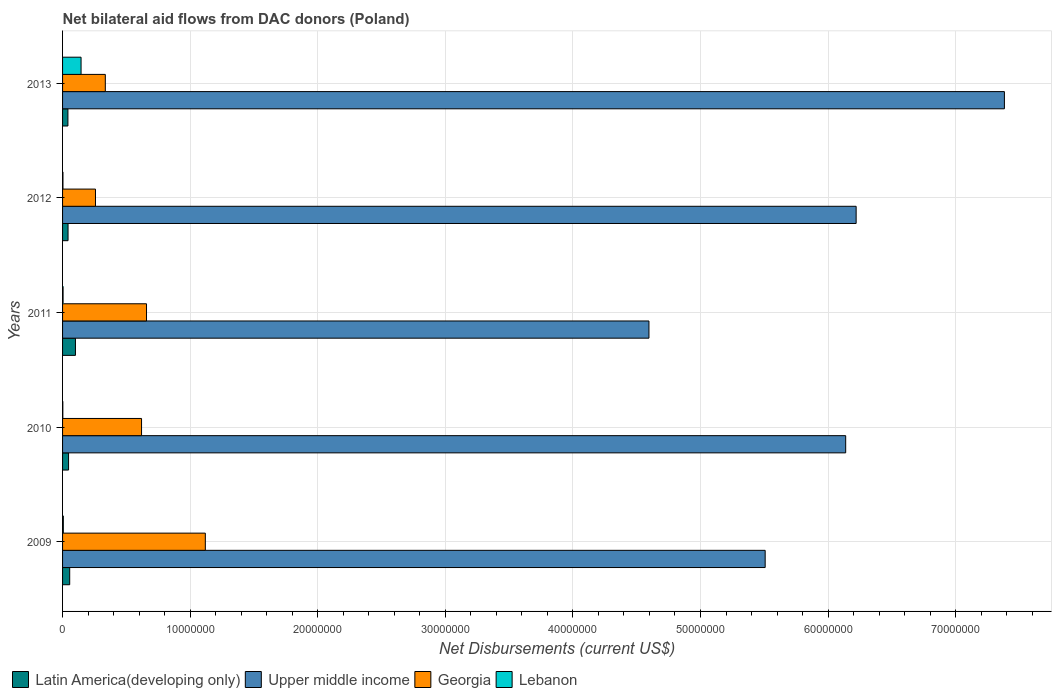How many bars are there on the 2nd tick from the top?
Provide a short and direct response. 4. What is the label of the 2nd group of bars from the top?
Your answer should be very brief. 2012. What is the net bilateral aid flows in Lebanon in 2012?
Provide a short and direct response. 3.00e+04. Across all years, what is the maximum net bilateral aid flows in Upper middle income?
Your answer should be compact. 7.38e+07. Across all years, what is the minimum net bilateral aid flows in Lebanon?
Make the answer very short. 2.00e+04. In which year was the net bilateral aid flows in Lebanon maximum?
Your response must be concise. 2013. What is the total net bilateral aid flows in Georgia in the graph?
Give a very brief answer. 2.99e+07. What is the difference between the net bilateral aid flows in Upper middle income in 2010 and that in 2013?
Ensure brevity in your answer.  -1.24e+07. What is the difference between the net bilateral aid flows in Georgia in 2010 and the net bilateral aid flows in Lebanon in 2013?
Offer a very short reply. 4.74e+06. In the year 2009, what is the difference between the net bilateral aid flows in Upper middle income and net bilateral aid flows in Latin America(developing only)?
Offer a very short reply. 5.45e+07. In how many years, is the net bilateral aid flows in Lebanon greater than 36000000 US$?
Your answer should be very brief. 0. What is the ratio of the net bilateral aid flows in Latin America(developing only) in 2009 to that in 2012?
Offer a very short reply. 1.3. What is the difference between the highest and the second highest net bilateral aid flows in Latin America(developing only)?
Your answer should be compact. 4.50e+05. What is the difference between the highest and the lowest net bilateral aid flows in Georgia?
Your answer should be compact. 8.61e+06. In how many years, is the net bilateral aid flows in Latin America(developing only) greater than the average net bilateral aid flows in Latin America(developing only) taken over all years?
Make the answer very short. 1. What does the 2nd bar from the top in 2013 represents?
Your response must be concise. Georgia. What does the 3rd bar from the bottom in 2012 represents?
Keep it short and to the point. Georgia. Is it the case that in every year, the sum of the net bilateral aid flows in Latin America(developing only) and net bilateral aid flows in Lebanon is greater than the net bilateral aid flows in Georgia?
Offer a terse response. No. Are the values on the major ticks of X-axis written in scientific E-notation?
Provide a short and direct response. No. Does the graph contain any zero values?
Your answer should be very brief. No. Does the graph contain grids?
Your response must be concise. Yes. What is the title of the graph?
Keep it short and to the point. Net bilateral aid flows from DAC donors (Poland). What is the label or title of the X-axis?
Provide a succinct answer. Net Disbursements (current US$). What is the Net Disbursements (current US$) of Latin America(developing only) in 2009?
Keep it short and to the point. 5.60e+05. What is the Net Disbursements (current US$) in Upper middle income in 2009?
Provide a short and direct response. 5.51e+07. What is the Net Disbursements (current US$) of Georgia in 2009?
Give a very brief answer. 1.12e+07. What is the Net Disbursements (current US$) in Upper middle income in 2010?
Offer a terse response. 6.14e+07. What is the Net Disbursements (current US$) of Georgia in 2010?
Your answer should be very brief. 6.19e+06. What is the Net Disbursements (current US$) in Lebanon in 2010?
Give a very brief answer. 2.00e+04. What is the Net Disbursements (current US$) in Latin America(developing only) in 2011?
Ensure brevity in your answer.  1.01e+06. What is the Net Disbursements (current US$) of Upper middle income in 2011?
Provide a short and direct response. 4.60e+07. What is the Net Disbursements (current US$) of Georgia in 2011?
Give a very brief answer. 6.58e+06. What is the Net Disbursements (current US$) of Lebanon in 2011?
Offer a terse response. 4.00e+04. What is the Net Disbursements (current US$) of Upper middle income in 2012?
Offer a terse response. 6.22e+07. What is the Net Disbursements (current US$) in Georgia in 2012?
Offer a very short reply. 2.58e+06. What is the Net Disbursements (current US$) of Lebanon in 2012?
Offer a very short reply. 3.00e+04. What is the Net Disbursements (current US$) in Upper middle income in 2013?
Offer a terse response. 7.38e+07. What is the Net Disbursements (current US$) of Georgia in 2013?
Provide a short and direct response. 3.35e+06. What is the Net Disbursements (current US$) in Lebanon in 2013?
Provide a succinct answer. 1.45e+06. Across all years, what is the maximum Net Disbursements (current US$) of Latin America(developing only)?
Your answer should be very brief. 1.01e+06. Across all years, what is the maximum Net Disbursements (current US$) of Upper middle income?
Offer a very short reply. 7.38e+07. Across all years, what is the maximum Net Disbursements (current US$) in Georgia?
Your answer should be compact. 1.12e+07. Across all years, what is the maximum Net Disbursements (current US$) in Lebanon?
Offer a terse response. 1.45e+06. Across all years, what is the minimum Net Disbursements (current US$) in Upper middle income?
Keep it short and to the point. 4.60e+07. Across all years, what is the minimum Net Disbursements (current US$) in Georgia?
Keep it short and to the point. 2.58e+06. What is the total Net Disbursements (current US$) in Latin America(developing only) in the graph?
Your answer should be compact. 2.89e+06. What is the total Net Disbursements (current US$) of Upper middle income in the graph?
Your answer should be compact. 2.98e+08. What is the total Net Disbursements (current US$) of Georgia in the graph?
Your answer should be very brief. 2.99e+07. What is the total Net Disbursements (current US$) of Lebanon in the graph?
Offer a terse response. 1.60e+06. What is the difference between the Net Disbursements (current US$) of Upper middle income in 2009 and that in 2010?
Provide a succinct answer. -6.31e+06. What is the difference between the Net Disbursements (current US$) of Georgia in 2009 and that in 2010?
Provide a short and direct response. 5.00e+06. What is the difference between the Net Disbursements (current US$) in Lebanon in 2009 and that in 2010?
Offer a very short reply. 4.00e+04. What is the difference between the Net Disbursements (current US$) of Latin America(developing only) in 2009 and that in 2011?
Offer a very short reply. -4.50e+05. What is the difference between the Net Disbursements (current US$) of Upper middle income in 2009 and that in 2011?
Provide a short and direct response. 9.11e+06. What is the difference between the Net Disbursements (current US$) in Georgia in 2009 and that in 2011?
Make the answer very short. 4.61e+06. What is the difference between the Net Disbursements (current US$) in Latin America(developing only) in 2009 and that in 2012?
Provide a succinct answer. 1.30e+05. What is the difference between the Net Disbursements (current US$) of Upper middle income in 2009 and that in 2012?
Keep it short and to the point. -7.13e+06. What is the difference between the Net Disbursements (current US$) in Georgia in 2009 and that in 2012?
Provide a short and direct response. 8.61e+06. What is the difference between the Net Disbursements (current US$) of Lebanon in 2009 and that in 2012?
Your answer should be very brief. 3.00e+04. What is the difference between the Net Disbursements (current US$) of Upper middle income in 2009 and that in 2013?
Your answer should be very brief. -1.88e+07. What is the difference between the Net Disbursements (current US$) of Georgia in 2009 and that in 2013?
Provide a succinct answer. 7.84e+06. What is the difference between the Net Disbursements (current US$) of Lebanon in 2009 and that in 2013?
Provide a succinct answer. -1.39e+06. What is the difference between the Net Disbursements (current US$) in Latin America(developing only) in 2010 and that in 2011?
Your response must be concise. -5.40e+05. What is the difference between the Net Disbursements (current US$) in Upper middle income in 2010 and that in 2011?
Your answer should be compact. 1.54e+07. What is the difference between the Net Disbursements (current US$) in Georgia in 2010 and that in 2011?
Offer a terse response. -3.90e+05. What is the difference between the Net Disbursements (current US$) in Upper middle income in 2010 and that in 2012?
Keep it short and to the point. -8.20e+05. What is the difference between the Net Disbursements (current US$) of Georgia in 2010 and that in 2012?
Keep it short and to the point. 3.61e+06. What is the difference between the Net Disbursements (current US$) in Lebanon in 2010 and that in 2012?
Provide a succinct answer. -10000. What is the difference between the Net Disbursements (current US$) in Latin America(developing only) in 2010 and that in 2013?
Provide a succinct answer. 5.00e+04. What is the difference between the Net Disbursements (current US$) of Upper middle income in 2010 and that in 2013?
Give a very brief answer. -1.24e+07. What is the difference between the Net Disbursements (current US$) of Georgia in 2010 and that in 2013?
Provide a succinct answer. 2.84e+06. What is the difference between the Net Disbursements (current US$) in Lebanon in 2010 and that in 2013?
Keep it short and to the point. -1.43e+06. What is the difference between the Net Disbursements (current US$) of Latin America(developing only) in 2011 and that in 2012?
Ensure brevity in your answer.  5.80e+05. What is the difference between the Net Disbursements (current US$) in Upper middle income in 2011 and that in 2012?
Your response must be concise. -1.62e+07. What is the difference between the Net Disbursements (current US$) of Georgia in 2011 and that in 2012?
Your answer should be very brief. 4.00e+06. What is the difference between the Net Disbursements (current US$) of Latin America(developing only) in 2011 and that in 2013?
Ensure brevity in your answer.  5.90e+05. What is the difference between the Net Disbursements (current US$) in Upper middle income in 2011 and that in 2013?
Your answer should be compact. -2.79e+07. What is the difference between the Net Disbursements (current US$) in Georgia in 2011 and that in 2013?
Ensure brevity in your answer.  3.23e+06. What is the difference between the Net Disbursements (current US$) of Lebanon in 2011 and that in 2013?
Keep it short and to the point. -1.41e+06. What is the difference between the Net Disbursements (current US$) in Latin America(developing only) in 2012 and that in 2013?
Keep it short and to the point. 10000. What is the difference between the Net Disbursements (current US$) in Upper middle income in 2012 and that in 2013?
Your response must be concise. -1.16e+07. What is the difference between the Net Disbursements (current US$) of Georgia in 2012 and that in 2013?
Make the answer very short. -7.70e+05. What is the difference between the Net Disbursements (current US$) in Lebanon in 2012 and that in 2013?
Give a very brief answer. -1.42e+06. What is the difference between the Net Disbursements (current US$) of Latin America(developing only) in 2009 and the Net Disbursements (current US$) of Upper middle income in 2010?
Provide a succinct answer. -6.08e+07. What is the difference between the Net Disbursements (current US$) in Latin America(developing only) in 2009 and the Net Disbursements (current US$) in Georgia in 2010?
Offer a very short reply. -5.63e+06. What is the difference between the Net Disbursements (current US$) of Latin America(developing only) in 2009 and the Net Disbursements (current US$) of Lebanon in 2010?
Give a very brief answer. 5.40e+05. What is the difference between the Net Disbursements (current US$) of Upper middle income in 2009 and the Net Disbursements (current US$) of Georgia in 2010?
Provide a succinct answer. 4.89e+07. What is the difference between the Net Disbursements (current US$) of Upper middle income in 2009 and the Net Disbursements (current US$) of Lebanon in 2010?
Keep it short and to the point. 5.50e+07. What is the difference between the Net Disbursements (current US$) of Georgia in 2009 and the Net Disbursements (current US$) of Lebanon in 2010?
Offer a very short reply. 1.12e+07. What is the difference between the Net Disbursements (current US$) of Latin America(developing only) in 2009 and the Net Disbursements (current US$) of Upper middle income in 2011?
Give a very brief answer. -4.54e+07. What is the difference between the Net Disbursements (current US$) in Latin America(developing only) in 2009 and the Net Disbursements (current US$) in Georgia in 2011?
Ensure brevity in your answer.  -6.02e+06. What is the difference between the Net Disbursements (current US$) of Latin America(developing only) in 2009 and the Net Disbursements (current US$) of Lebanon in 2011?
Offer a terse response. 5.20e+05. What is the difference between the Net Disbursements (current US$) in Upper middle income in 2009 and the Net Disbursements (current US$) in Georgia in 2011?
Provide a short and direct response. 4.85e+07. What is the difference between the Net Disbursements (current US$) of Upper middle income in 2009 and the Net Disbursements (current US$) of Lebanon in 2011?
Your response must be concise. 5.50e+07. What is the difference between the Net Disbursements (current US$) of Georgia in 2009 and the Net Disbursements (current US$) of Lebanon in 2011?
Keep it short and to the point. 1.12e+07. What is the difference between the Net Disbursements (current US$) in Latin America(developing only) in 2009 and the Net Disbursements (current US$) in Upper middle income in 2012?
Your answer should be compact. -6.16e+07. What is the difference between the Net Disbursements (current US$) of Latin America(developing only) in 2009 and the Net Disbursements (current US$) of Georgia in 2012?
Provide a succinct answer. -2.02e+06. What is the difference between the Net Disbursements (current US$) of Latin America(developing only) in 2009 and the Net Disbursements (current US$) of Lebanon in 2012?
Your answer should be compact. 5.30e+05. What is the difference between the Net Disbursements (current US$) in Upper middle income in 2009 and the Net Disbursements (current US$) in Georgia in 2012?
Your answer should be very brief. 5.25e+07. What is the difference between the Net Disbursements (current US$) of Upper middle income in 2009 and the Net Disbursements (current US$) of Lebanon in 2012?
Your answer should be compact. 5.50e+07. What is the difference between the Net Disbursements (current US$) of Georgia in 2009 and the Net Disbursements (current US$) of Lebanon in 2012?
Provide a short and direct response. 1.12e+07. What is the difference between the Net Disbursements (current US$) in Latin America(developing only) in 2009 and the Net Disbursements (current US$) in Upper middle income in 2013?
Provide a succinct answer. -7.33e+07. What is the difference between the Net Disbursements (current US$) in Latin America(developing only) in 2009 and the Net Disbursements (current US$) in Georgia in 2013?
Offer a terse response. -2.79e+06. What is the difference between the Net Disbursements (current US$) in Latin America(developing only) in 2009 and the Net Disbursements (current US$) in Lebanon in 2013?
Provide a succinct answer. -8.90e+05. What is the difference between the Net Disbursements (current US$) in Upper middle income in 2009 and the Net Disbursements (current US$) in Georgia in 2013?
Give a very brief answer. 5.17e+07. What is the difference between the Net Disbursements (current US$) in Upper middle income in 2009 and the Net Disbursements (current US$) in Lebanon in 2013?
Offer a very short reply. 5.36e+07. What is the difference between the Net Disbursements (current US$) in Georgia in 2009 and the Net Disbursements (current US$) in Lebanon in 2013?
Offer a very short reply. 9.74e+06. What is the difference between the Net Disbursements (current US$) of Latin America(developing only) in 2010 and the Net Disbursements (current US$) of Upper middle income in 2011?
Give a very brief answer. -4.55e+07. What is the difference between the Net Disbursements (current US$) in Latin America(developing only) in 2010 and the Net Disbursements (current US$) in Georgia in 2011?
Your answer should be compact. -6.11e+06. What is the difference between the Net Disbursements (current US$) in Upper middle income in 2010 and the Net Disbursements (current US$) in Georgia in 2011?
Your answer should be compact. 5.48e+07. What is the difference between the Net Disbursements (current US$) of Upper middle income in 2010 and the Net Disbursements (current US$) of Lebanon in 2011?
Your response must be concise. 6.13e+07. What is the difference between the Net Disbursements (current US$) in Georgia in 2010 and the Net Disbursements (current US$) in Lebanon in 2011?
Provide a succinct answer. 6.15e+06. What is the difference between the Net Disbursements (current US$) in Latin America(developing only) in 2010 and the Net Disbursements (current US$) in Upper middle income in 2012?
Ensure brevity in your answer.  -6.17e+07. What is the difference between the Net Disbursements (current US$) in Latin America(developing only) in 2010 and the Net Disbursements (current US$) in Georgia in 2012?
Keep it short and to the point. -2.11e+06. What is the difference between the Net Disbursements (current US$) of Latin America(developing only) in 2010 and the Net Disbursements (current US$) of Lebanon in 2012?
Provide a short and direct response. 4.40e+05. What is the difference between the Net Disbursements (current US$) of Upper middle income in 2010 and the Net Disbursements (current US$) of Georgia in 2012?
Give a very brief answer. 5.88e+07. What is the difference between the Net Disbursements (current US$) in Upper middle income in 2010 and the Net Disbursements (current US$) in Lebanon in 2012?
Your answer should be very brief. 6.14e+07. What is the difference between the Net Disbursements (current US$) in Georgia in 2010 and the Net Disbursements (current US$) in Lebanon in 2012?
Your answer should be very brief. 6.16e+06. What is the difference between the Net Disbursements (current US$) of Latin America(developing only) in 2010 and the Net Disbursements (current US$) of Upper middle income in 2013?
Provide a short and direct response. -7.34e+07. What is the difference between the Net Disbursements (current US$) in Latin America(developing only) in 2010 and the Net Disbursements (current US$) in Georgia in 2013?
Provide a short and direct response. -2.88e+06. What is the difference between the Net Disbursements (current US$) in Latin America(developing only) in 2010 and the Net Disbursements (current US$) in Lebanon in 2013?
Ensure brevity in your answer.  -9.80e+05. What is the difference between the Net Disbursements (current US$) of Upper middle income in 2010 and the Net Disbursements (current US$) of Georgia in 2013?
Your answer should be compact. 5.80e+07. What is the difference between the Net Disbursements (current US$) of Upper middle income in 2010 and the Net Disbursements (current US$) of Lebanon in 2013?
Provide a succinct answer. 5.99e+07. What is the difference between the Net Disbursements (current US$) in Georgia in 2010 and the Net Disbursements (current US$) in Lebanon in 2013?
Give a very brief answer. 4.74e+06. What is the difference between the Net Disbursements (current US$) of Latin America(developing only) in 2011 and the Net Disbursements (current US$) of Upper middle income in 2012?
Offer a very short reply. -6.12e+07. What is the difference between the Net Disbursements (current US$) of Latin America(developing only) in 2011 and the Net Disbursements (current US$) of Georgia in 2012?
Your answer should be very brief. -1.57e+06. What is the difference between the Net Disbursements (current US$) in Latin America(developing only) in 2011 and the Net Disbursements (current US$) in Lebanon in 2012?
Make the answer very short. 9.80e+05. What is the difference between the Net Disbursements (current US$) in Upper middle income in 2011 and the Net Disbursements (current US$) in Georgia in 2012?
Make the answer very short. 4.34e+07. What is the difference between the Net Disbursements (current US$) of Upper middle income in 2011 and the Net Disbursements (current US$) of Lebanon in 2012?
Provide a short and direct response. 4.59e+07. What is the difference between the Net Disbursements (current US$) in Georgia in 2011 and the Net Disbursements (current US$) in Lebanon in 2012?
Give a very brief answer. 6.55e+06. What is the difference between the Net Disbursements (current US$) of Latin America(developing only) in 2011 and the Net Disbursements (current US$) of Upper middle income in 2013?
Provide a short and direct response. -7.28e+07. What is the difference between the Net Disbursements (current US$) in Latin America(developing only) in 2011 and the Net Disbursements (current US$) in Georgia in 2013?
Keep it short and to the point. -2.34e+06. What is the difference between the Net Disbursements (current US$) of Latin America(developing only) in 2011 and the Net Disbursements (current US$) of Lebanon in 2013?
Offer a very short reply. -4.40e+05. What is the difference between the Net Disbursements (current US$) in Upper middle income in 2011 and the Net Disbursements (current US$) in Georgia in 2013?
Give a very brief answer. 4.26e+07. What is the difference between the Net Disbursements (current US$) in Upper middle income in 2011 and the Net Disbursements (current US$) in Lebanon in 2013?
Your response must be concise. 4.45e+07. What is the difference between the Net Disbursements (current US$) in Georgia in 2011 and the Net Disbursements (current US$) in Lebanon in 2013?
Provide a succinct answer. 5.13e+06. What is the difference between the Net Disbursements (current US$) in Latin America(developing only) in 2012 and the Net Disbursements (current US$) in Upper middle income in 2013?
Give a very brief answer. -7.34e+07. What is the difference between the Net Disbursements (current US$) of Latin America(developing only) in 2012 and the Net Disbursements (current US$) of Georgia in 2013?
Offer a terse response. -2.92e+06. What is the difference between the Net Disbursements (current US$) in Latin America(developing only) in 2012 and the Net Disbursements (current US$) in Lebanon in 2013?
Your answer should be compact. -1.02e+06. What is the difference between the Net Disbursements (current US$) of Upper middle income in 2012 and the Net Disbursements (current US$) of Georgia in 2013?
Give a very brief answer. 5.88e+07. What is the difference between the Net Disbursements (current US$) of Upper middle income in 2012 and the Net Disbursements (current US$) of Lebanon in 2013?
Your answer should be compact. 6.08e+07. What is the difference between the Net Disbursements (current US$) in Georgia in 2012 and the Net Disbursements (current US$) in Lebanon in 2013?
Offer a terse response. 1.13e+06. What is the average Net Disbursements (current US$) of Latin America(developing only) per year?
Provide a succinct answer. 5.78e+05. What is the average Net Disbursements (current US$) of Upper middle income per year?
Offer a very short reply. 5.97e+07. What is the average Net Disbursements (current US$) in Georgia per year?
Offer a terse response. 5.98e+06. What is the average Net Disbursements (current US$) in Lebanon per year?
Your response must be concise. 3.20e+05. In the year 2009, what is the difference between the Net Disbursements (current US$) in Latin America(developing only) and Net Disbursements (current US$) in Upper middle income?
Ensure brevity in your answer.  -5.45e+07. In the year 2009, what is the difference between the Net Disbursements (current US$) in Latin America(developing only) and Net Disbursements (current US$) in Georgia?
Your answer should be very brief. -1.06e+07. In the year 2009, what is the difference between the Net Disbursements (current US$) of Latin America(developing only) and Net Disbursements (current US$) of Lebanon?
Keep it short and to the point. 5.00e+05. In the year 2009, what is the difference between the Net Disbursements (current US$) in Upper middle income and Net Disbursements (current US$) in Georgia?
Ensure brevity in your answer.  4.39e+07. In the year 2009, what is the difference between the Net Disbursements (current US$) in Upper middle income and Net Disbursements (current US$) in Lebanon?
Your response must be concise. 5.50e+07. In the year 2009, what is the difference between the Net Disbursements (current US$) of Georgia and Net Disbursements (current US$) of Lebanon?
Your response must be concise. 1.11e+07. In the year 2010, what is the difference between the Net Disbursements (current US$) in Latin America(developing only) and Net Disbursements (current US$) in Upper middle income?
Your answer should be compact. -6.09e+07. In the year 2010, what is the difference between the Net Disbursements (current US$) of Latin America(developing only) and Net Disbursements (current US$) of Georgia?
Your response must be concise. -5.72e+06. In the year 2010, what is the difference between the Net Disbursements (current US$) of Latin America(developing only) and Net Disbursements (current US$) of Lebanon?
Offer a very short reply. 4.50e+05. In the year 2010, what is the difference between the Net Disbursements (current US$) of Upper middle income and Net Disbursements (current US$) of Georgia?
Ensure brevity in your answer.  5.52e+07. In the year 2010, what is the difference between the Net Disbursements (current US$) in Upper middle income and Net Disbursements (current US$) in Lebanon?
Provide a short and direct response. 6.14e+07. In the year 2010, what is the difference between the Net Disbursements (current US$) of Georgia and Net Disbursements (current US$) of Lebanon?
Offer a very short reply. 6.17e+06. In the year 2011, what is the difference between the Net Disbursements (current US$) of Latin America(developing only) and Net Disbursements (current US$) of Upper middle income?
Your response must be concise. -4.50e+07. In the year 2011, what is the difference between the Net Disbursements (current US$) in Latin America(developing only) and Net Disbursements (current US$) in Georgia?
Provide a succinct answer. -5.57e+06. In the year 2011, what is the difference between the Net Disbursements (current US$) in Latin America(developing only) and Net Disbursements (current US$) in Lebanon?
Keep it short and to the point. 9.70e+05. In the year 2011, what is the difference between the Net Disbursements (current US$) of Upper middle income and Net Disbursements (current US$) of Georgia?
Make the answer very short. 3.94e+07. In the year 2011, what is the difference between the Net Disbursements (current US$) of Upper middle income and Net Disbursements (current US$) of Lebanon?
Offer a very short reply. 4.59e+07. In the year 2011, what is the difference between the Net Disbursements (current US$) of Georgia and Net Disbursements (current US$) of Lebanon?
Ensure brevity in your answer.  6.54e+06. In the year 2012, what is the difference between the Net Disbursements (current US$) in Latin America(developing only) and Net Disbursements (current US$) in Upper middle income?
Keep it short and to the point. -6.18e+07. In the year 2012, what is the difference between the Net Disbursements (current US$) in Latin America(developing only) and Net Disbursements (current US$) in Georgia?
Give a very brief answer. -2.15e+06. In the year 2012, what is the difference between the Net Disbursements (current US$) in Latin America(developing only) and Net Disbursements (current US$) in Lebanon?
Provide a succinct answer. 4.00e+05. In the year 2012, what is the difference between the Net Disbursements (current US$) of Upper middle income and Net Disbursements (current US$) of Georgia?
Your answer should be compact. 5.96e+07. In the year 2012, what is the difference between the Net Disbursements (current US$) in Upper middle income and Net Disbursements (current US$) in Lebanon?
Give a very brief answer. 6.22e+07. In the year 2012, what is the difference between the Net Disbursements (current US$) in Georgia and Net Disbursements (current US$) in Lebanon?
Provide a succinct answer. 2.55e+06. In the year 2013, what is the difference between the Net Disbursements (current US$) of Latin America(developing only) and Net Disbursements (current US$) of Upper middle income?
Offer a very short reply. -7.34e+07. In the year 2013, what is the difference between the Net Disbursements (current US$) in Latin America(developing only) and Net Disbursements (current US$) in Georgia?
Your answer should be very brief. -2.93e+06. In the year 2013, what is the difference between the Net Disbursements (current US$) in Latin America(developing only) and Net Disbursements (current US$) in Lebanon?
Make the answer very short. -1.03e+06. In the year 2013, what is the difference between the Net Disbursements (current US$) of Upper middle income and Net Disbursements (current US$) of Georgia?
Your response must be concise. 7.05e+07. In the year 2013, what is the difference between the Net Disbursements (current US$) in Upper middle income and Net Disbursements (current US$) in Lebanon?
Make the answer very short. 7.24e+07. In the year 2013, what is the difference between the Net Disbursements (current US$) of Georgia and Net Disbursements (current US$) of Lebanon?
Your response must be concise. 1.90e+06. What is the ratio of the Net Disbursements (current US$) in Latin America(developing only) in 2009 to that in 2010?
Make the answer very short. 1.19. What is the ratio of the Net Disbursements (current US$) of Upper middle income in 2009 to that in 2010?
Give a very brief answer. 0.9. What is the ratio of the Net Disbursements (current US$) of Georgia in 2009 to that in 2010?
Give a very brief answer. 1.81. What is the ratio of the Net Disbursements (current US$) of Lebanon in 2009 to that in 2010?
Provide a succinct answer. 3. What is the ratio of the Net Disbursements (current US$) in Latin America(developing only) in 2009 to that in 2011?
Your answer should be very brief. 0.55. What is the ratio of the Net Disbursements (current US$) of Upper middle income in 2009 to that in 2011?
Offer a terse response. 1.2. What is the ratio of the Net Disbursements (current US$) of Georgia in 2009 to that in 2011?
Offer a terse response. 1.7. What is the ratio of the Net Disbursements (current US$) of Lebanon in 2009 to that in 2011?
Give a very brief answer. 1.5. What is the ratio of the Net Disbursements (current US$) of Latin America(developing only) in 2009 to that in 2012?
Provide a short and direct response. 1.3. What is the ratio of the Net Disbursements (current US$) in Upper middle income in 2009 to that in 2012?
Make the answer very short. 0.89. What is the ratio of the Net Disbursements (current US$) of Georgia in 2009 to that in 2012?
Make the answer very short. 4.34. What is the ratio of the Net Disbursements (current US$) of Upper middle income in 2009 to that in 2013?
Your answer should be very brief. 0.75. What is the ratio of the Net Disbursements (current US$) in Georgia in 2009 to that in 2013?
Give a very brief answer. 3.34. What is the ratio of the Net Disbursements (current US$) in Lebanon in 2009 to that in 2013?
Your answer should be very brief. 0.04. What is the ratio of the Net Disbursements (current US$) of Latin America(developing only) in 2010 to that in 2011?
Your answer should be compact. 0.47. What is the ratio of the Net Disbursements (current US$) in Upper middle income in 2010 to that in 2011?
Provide a short and direct response. 1.34. What is the ratio of the Net Disbursements (current US$) in Georgia in 2010 to that in 2011?
Offer a terse response. 0.94. What is the ratio of the Net Disbursements (current US$) in Latin America(developing only) in 2010 to that in 2012?
Provide a succinct answer. 1.09. What is the ratio of the Net Disbursements (current US$) of Upper middle income in 2010 to that in 2012?
Your answer should be compact. 0.99. What is the ratio of the Net Disbursements (current US$) of Georgia in 2010 to that in 2012?
Make the answer very short. 2.4. What is the ratio of the Net Disbursements (current US$) of Lebanon in 2010 to that in 2012?
Ensure brevity in your answer.  0.67. What is the ratio of the Net Disbursements (current US$) of Latin America(developing only) in 2010 to that in 2013?
Make the answer very short. 1.12. What is the ratio of the Net Disbursements (current US$) in Upper middle income in 2010 to that in 2013?
Keep it short and to the point. 0.83. What is the ratio of the Net Disbursements (current US$) in Georgia in 2010 to that in 2013?
Give a very brief answer. 1.85. What is the ratio of the Net Disbursements (current US$) of Lebanon in 2010 to that in 2013?
Offer a very short reply. 0.01. What is the ratio of the Net Disbursements (current US$) in Latin America(developing only) in 2011 to that in 2012?
Your answer should be very brief. 2.35. What is the ratio of the Net Disbursements (current US$) in Upper middle income in 2011 to that in 2012?
Provide a short and direct response. 0.74. What is the ratio of the Net Disbursements (current US$) in Georgia in 2011 to that in 2012?
Keep it short and to the point. 2.55. What is the ratio of the Net Disbursements (current US$) of Latin America(developing only) in 2011 to that in 2013?
Your response must be concise. 2.4. What is the ratio of the Net Disbursements (current US$) of Upper middle income in 2011 to that in 2013?
Make the answer very short. 0.62. What is the ratio of the Net Disbursements (current US$) in Georgia in 2011 to that in 2013?
Make the answer very short. 1.96. What is the ratio of the Net Disbursements (current US$) of Lebanon in 2011 to that in 2013?
Provide a succinct answer. 0.03. What is the ratio of the Net Disbursements (current US$) in Latin America(developing only) in 2012 to that in 2013?
Your response must be concise. 1.02. What is the ratio of the Net Disbursements (current US$) in Upper middle income in 2012 to that in 2013?
Provide a succinct answer. 0.84. What is the ratio of the Net Disbursements (current US$) of Georgia in 2012 to that in 2013?
Provide a short and direct response. 0.77. What is the ratio of the Net Disbursements (current US$) of Lebanon in 2012 to that in 2013?
Offer a very short reply. 0.02. What is the difference between the highest and the second highest Net Disbursements (current US$) in Latin America(developing only)?
Ensure brevity in your answer.  4.50e+05. What is the difference between the highest and the second highest Net Disbursements (current US$) of Upper middle income?
Provide a short and direct response. 1.16e+07. What is the difference between the highest and the second highest Net Disbursements (current US$) of Georgia?
Provide a succinct answer. 4.61e+06. What is the difference between the highest and the second highest Net Disbursements (current US$) in Lebanon?
Keep it short and to the point. 1.39e+06. What is the difference between the highest and the lowest Net Disbursements (current US$) in Latin America(developing only)?
Ensure brevity in your answer.  5.90e+05. What is the difference between the highest and the lowest Net Disbursements (current US$) in Upper middle income?
Make the answer very short. 2.79e+07. What is the difference between the highest and the lowest Net Disbursements (current US$) in Georgia?
Your answer should be compact. 8.61e+06. What is the difference between the highest and the lowest Net Disbursements (current US$) of Lebanon?
Keep it short and to the point. 1.43e+06. 